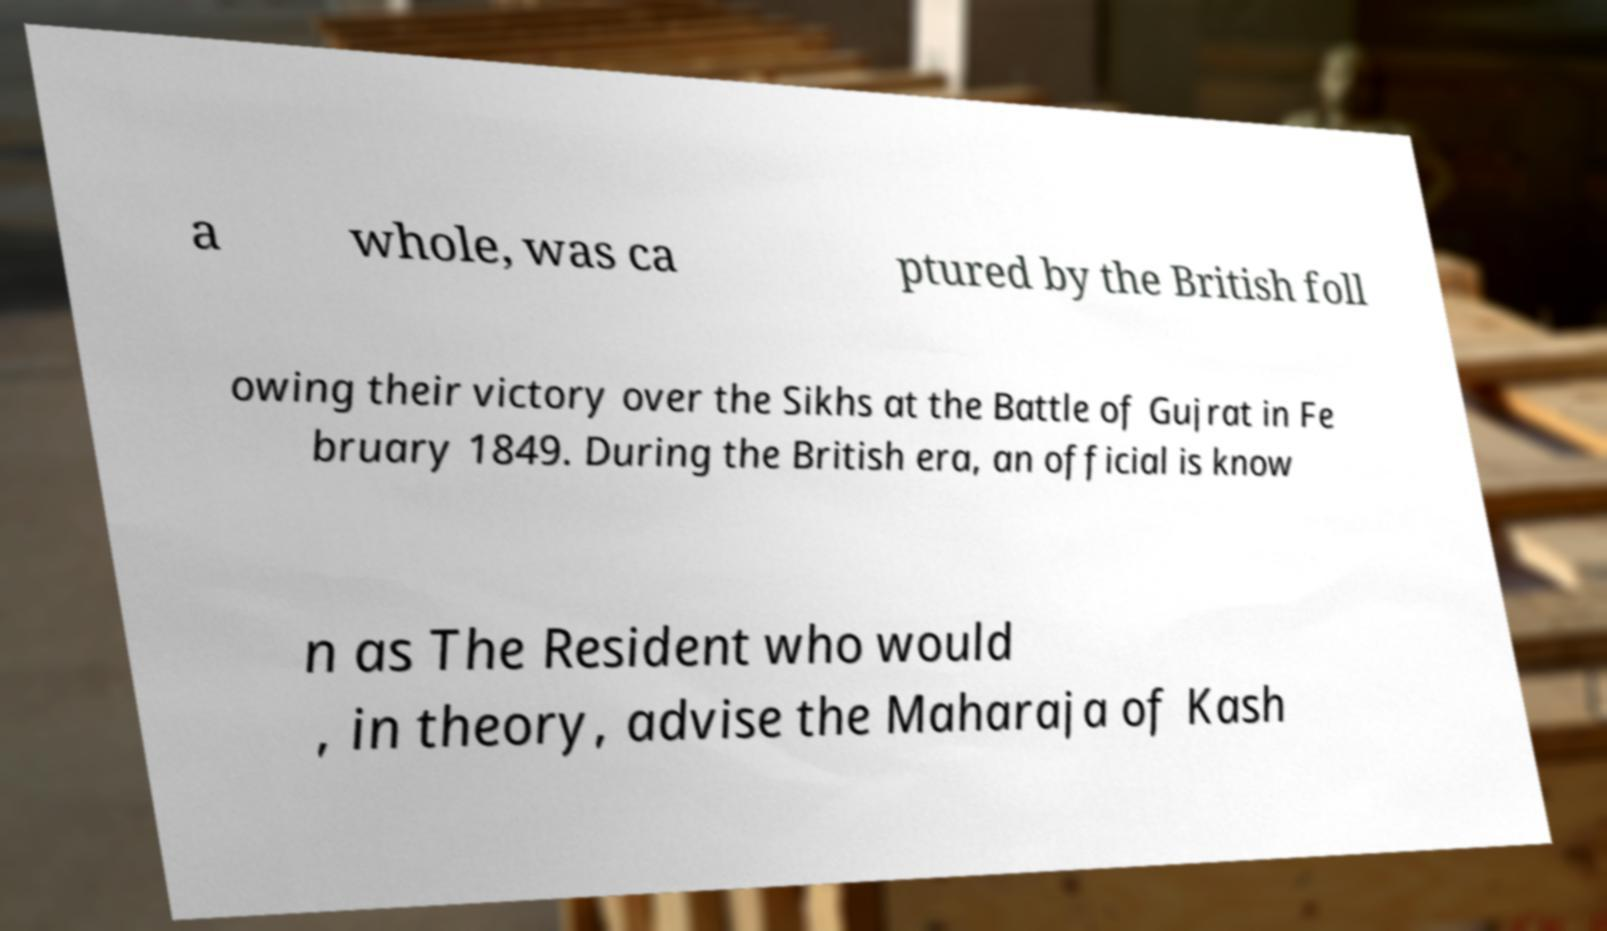What messages or text are displayed in this image? I need them in a readable, typed format. a whole, was ca ptured by the British foll owing their victory over the Sikhs at the Battle of Gujrat in Fe bruary 1849. During the British era, an official is know n as The Resident who would , in theory, advise the Maharaja of Kash 